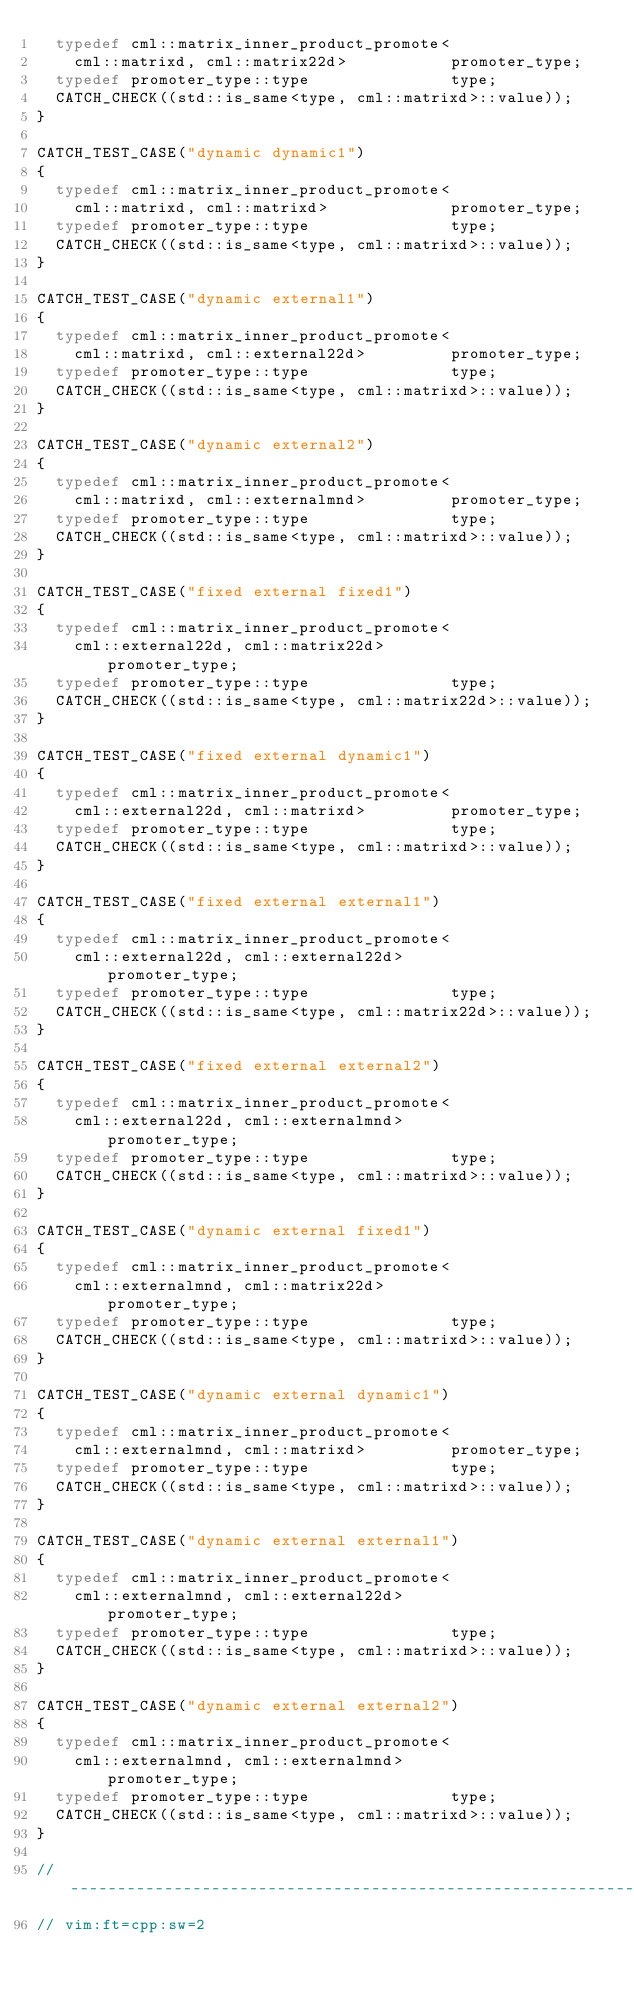<code> <loc_0><loc_0><loc_500><loc_500><_C++_>  typedef cml::matrix_inner_product_promote<
    cml::matrixd, cml::matrix22d>			promoter_type;
  typedef promoter_type::type				type;
  CATCH_CHECK((std::is_same<type, cml::matrixd>::value));
}

CATCH_TEST_CASE("dynamic dynamic1")
{
  typedef cml::matrix_inner_product_promote<
    cml::matrixd, cml::matrixd>				promoter_type;
  typedef promoter_type::type				type;
  CATCH_CHECK((std::is_same<type, cml::matrixd>::value));
}

CATCH_TEST_CASE("dynamic external1")
{
  typedef cml::matrix_inner_product_promote<
    cml::matrixd, cml::external22d>			promoter_type;
  typedef promoter_type::type				type;
  CATCH_CHECK((std::is_same<type, cml::matrixd>::value));
}

CATCH_TEST_CASE("dynamic external2")
{
  typedef cml::matrix_inner_product_promote<
    cml::matrixd, cml::externalmnd>			promoter_type;
  typedef promoter_type::type				type;
  CATCH_CHECK((std::is_same<type, cml::matrixd>::value));
}

CATCH_TEST_CASE("fixed external fixed1")
{
  typedef cml::matrix_inner_product_promote<
    cml::external22d, cml::matrix22d>			promoter_type;
  typedef promoter_type::type				type;
  CATCH_CHECK((std::is_same<type, cml::matrix22d>::value));
}

CATCH_TEST_CASE("fixed external dynamic1")
{
  typedef cml::matrix_inner_product_promote<
    cml::external22d, cml::matrixd>			promoter_type;
  typedef promoter_type::type				type;
  CATCH_CHECK((std::is_same<type, cml::matrixd>::value));
}

CATCH_TEST_CASE("fixed external external1")
{
  typedef cml::matrix_inner_product_promote<
    cml::external22d, cml::external22d>			promoter_type;
  typedef promoter_type::type				type;
  CATCH_CHECK((std::is_same<type, cml::matrix22d>::value));
}

CATCH_TEST_CASE("fixed external external2")
{
  typedef cml::matrix_inner_product_promote<
    cml::external22d, cml::externalmnd>			promoter_type;
  typedef promoter_type::type				type;
  CATCH_CHECK((std::is_same<type, cml::matrixd>::value));
}

CATCH_TEST_CASE("dynamic external fixed1")
{
  typedef cml::matrix_inner_product_promote<
    cml::externalmnd, cml::matrix22d>			promoter_type;
  typedef promoter_type::type				type;
  CATCH_CHECK((std::is_same<type, cml::matrixd>::value));
}

CATCH_TEST_CASE("dynamic external dynamic1")
{
  typedef cml::matrix_inner_product_promote<
    cml::externalmnd, cml::matrixd>			promoter_type;
  typedef promoter_type::type				type;
  CATCH_CHECK((std::is_same<type, cml::matrixd>::value));
}

CATCH_TEST_CASE("dynamic external external1")
{
  typedef cml::matrix_inner_product_promote<
    cml::externalmnd, cml::external22d>			promoter_type;
  typedef promoter_type::type				type;
  CATCH_CHECK((std::is_same<type, cml::matrixd>::value));
}

CATCH_TEST_CASE("dynamic external external2")
{
  typedef cml::matrix_inner_product_promote<
    cml::externalmnd, cml::externalmnd>			promoter_type;
  typedef promoter_type::type				type;
  CATCH_CHECK((std::is_same<type, cml::matrixd>::value));
}

// -------------------------------------------------------------------------
// vim:ft=cpp:sw=2
</code> 